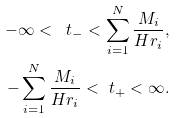<formula> <loc_0><loc_0><loc_500><loc_500>- \infty < \ t _ { - } < \sum _ { i = 1 } ^ { N } \frac { M _ { i } } { H r _ { i } } , \\ - \sum _ { i = 1 } ^ { N } \frac { M _ { i } } { H r _ { i } } < \ t _ { + } < \infty .</formula> 